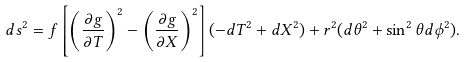Convert formula to latex. <formula><loc_0><loc_0><loc_500><loc_500>d s ^ { 2 } = f \left [ \left ( \frac { \partial g } { \partial T } \right ) ^ { 2 } - \left ( \frac { \partial g } { \partial X } \right ) ^ { 2 } \right ] ( - d T ^ { 2 } + d X ^ { 2 } ) + r ^ { 2 } ( d \theta ^ { 2 } + \sin ^ { 2 } \theta d \phi ^ { 2 } ) .</formula> 